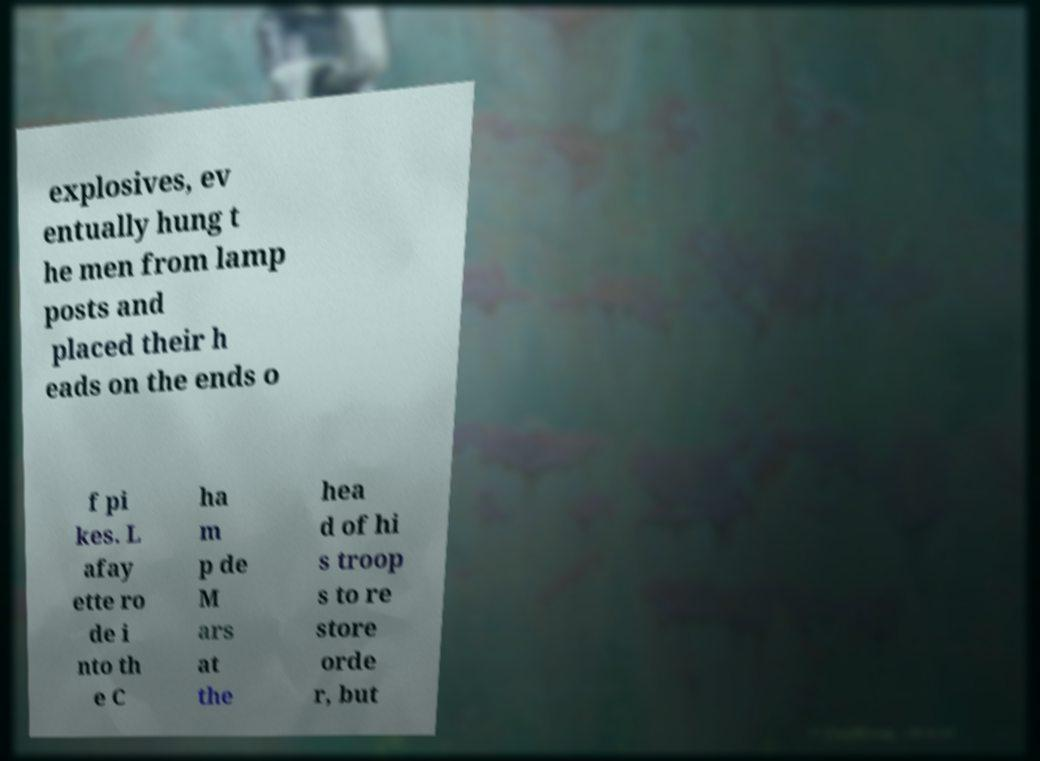I need the written content from this picture converted into text. Can you do that? explosives, ev entually hung t he men from lamp posts and placed their h eads on the ends o f pi kes. L afay ette ro de i nto th e C ha m p de M ars at the hea d of hi s troop s to re store orde r, but 